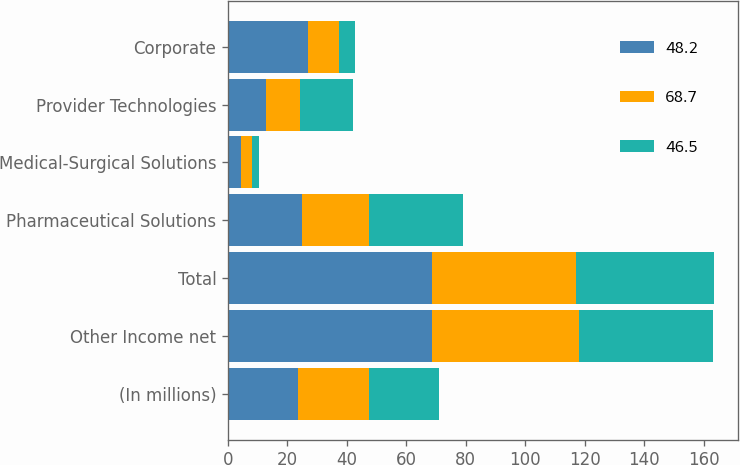Convert chart. <chart><loc_0><loc_0><loc_500><loc_500><stacked_bar_chart><ecel><fcel>(In millions)<fcel>Other Income net<fcel>Total<fcel>Pharmaceutical Solutions<fcel>Medical-Surgical Solutions<fcel>Provider Technologies<fcel>Corporate<nl><fcel>48.2<fcel>23.7<fcel>68.7<fcel>68.7<fcel>24.9<fcel>4.3<fcel>12.7<fcel>26.8<nl><fcel>68.7<fcel>23.7<fcel>49.4<fcel>48.2<fcel>22.5<fcel>3.7<fcel>11.5<fcel>10.5<nl><fcel>46.5<fcel>23.7<fcel>45.1<fcel>46.5<fcel>31.6<fcel>2.3<fcel>17.9<fcel>5.3<nl></chart> 